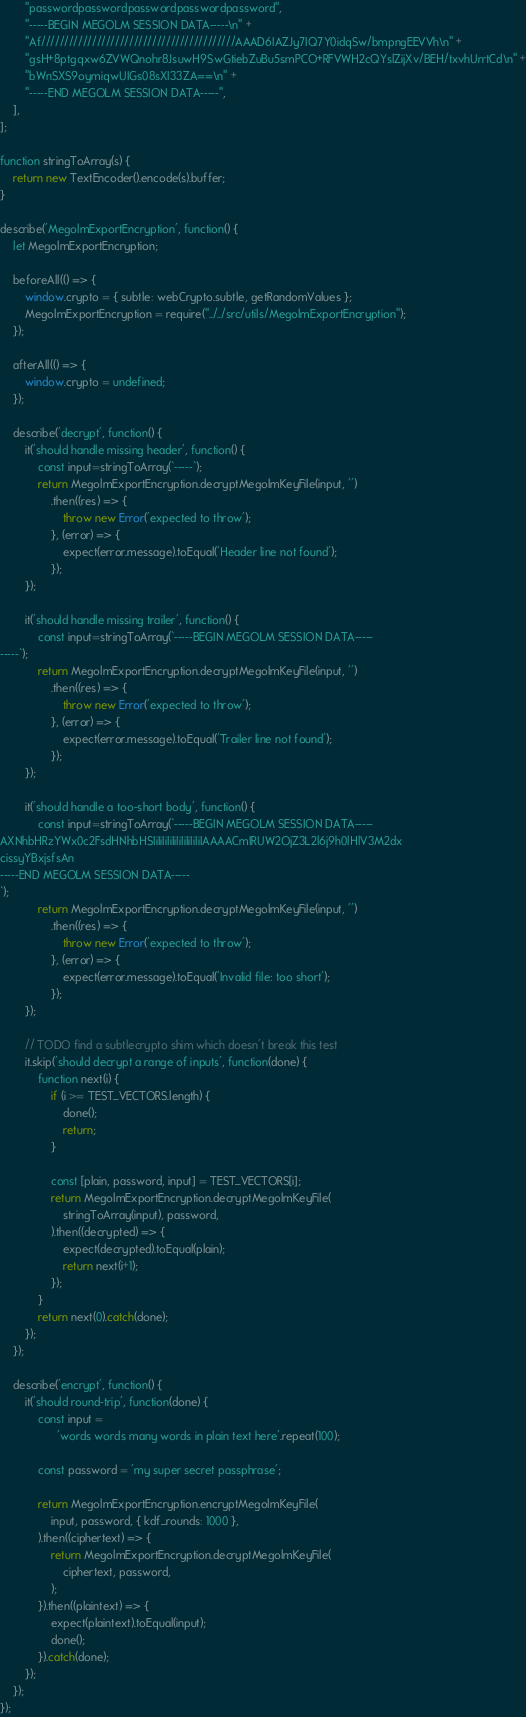<code> <loc_0><loc_0><loc_500><loc_500><_JavaScript_>        "passwordpasswordpasswordpasswordpassword",
        "-----BEGIN MEGOLM SESSION DATA-----\n" +
        "Af//////////////////////////////////////////AAAD6IAZJy7IQ7Y0idqSw/bmpngEEVVh\n" +
        "gsH+8ptgqxw6ZVWQnohr8JsuwH9SwGtiebZuBu5smPCO+RFVWH2cQYslZijXv/BEH/txvhUrrtCd\n" +
        "bWnSXS9oymiqwUIGs08sXI33ZA==\n" +
        "-----END MEGOLM SESSION DATA-----",
    ],
];

function stringToArray(s) {
    return new TextEncoder().encode(s).buffer;
}

describe('MegolmExportEncryption', function() {
    let MegolmExportEncryption;

    beforeAll(() => {
        window.crypto = { subtle: webCrypto.subtle, getRandomValues };
        MegolmExportEncryption = require("../../src/utils/MegolmExportEncryption");
    });

    afterAll(() => {
        window.crypto = undefined;
    });

    describe('decrypt', function() {
        it('should handle missing header', function() {
            const input=stringToArray(`-----`);
            return MegolmExportEncryption.decryptMegolmKeyFile(input, '')
                .then((res) => {
                    throw new Error('expected to throw');
                }, (error) => {
                    expect(error.message).toEqual('Header line not found');
                });
        });

        it('should handle missing trailer', function() {
            const input=stringToArray(`-----BEGIN MEGOLM SESSION DATA-----
-----`);
            return MegolmExportEncryption.decryptMegolmKeyFile(input, '')
                .then((res) => {
                    throw new Error('expected to throw');
                }, (error) => {
                    expect(error.message).toEqual('Trailer line not found');
                });
        });

        it('should handle a too-short body', function() {
            const input=stringToArray(`-----BEGIN MEGOLM SESSION DATA-----
AXNhbHRzYWx0c2FsdHNhbHSIiIiIiIiIiIiIiIiIiIiIAAAACmIRUW2OjZ3L2l6j9h0lHlV3M2dx
cissyYBxjsfsAn
-----END MEGOLM SESSION DATA-----
`);
            return MegolmExportEncryption.decryptMegolmKeyFile(input, '')
                .then((res) => {
                    throw new Error('expected to throw');
                }, (error) => {
                    expect(error.message).toEqual('Invalid file: too short');
                });
        });

        // TODO find a subtlecrypto shim which doesn't break this test
        it.skip('should decrypt a range of inputs', function(done) {
            function next(i) {
                if (i >= TEST_VECTORS.length) {
                    done();
                    return;
                }

                const [plain, password, input] = TEST_VECTORS[i];
                return MegolmExportEncryption.decryptMegolmKeyFile(
                    stringToArray(input), password,
                ).then((decrypted) => {
                    expect(decrypted).toEqual(plain);
                    return next(i+1);
                });
            }
            return next(0).catch(done);
        });
    });

    describe('encrypt', function() {
        it('should round-trip', function(done) {
            const input =
                  'words words many words in plain text here'.repeat(100);

            const password = 'my super secret passphrase';

            return MegolmExportEncryption.encryptMegolmKeyFile(
                input, password, { kdf_rounds: 1000 },
            ).then((ciphertext) => {
                return MegolmExportEncryption.decryptMegolmKeyFile(
                    ciphertext, password,
                );
            }).then((plaintext) => {
                expect(plaintext).toEqual(input);
                done();
            }).catch(done);
        });
    });
});
</code> 